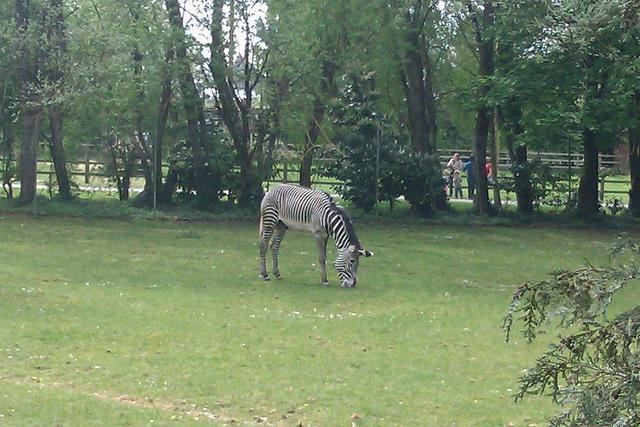How many blue frosted donuts can you count?
Give a very brief answer. 0. 